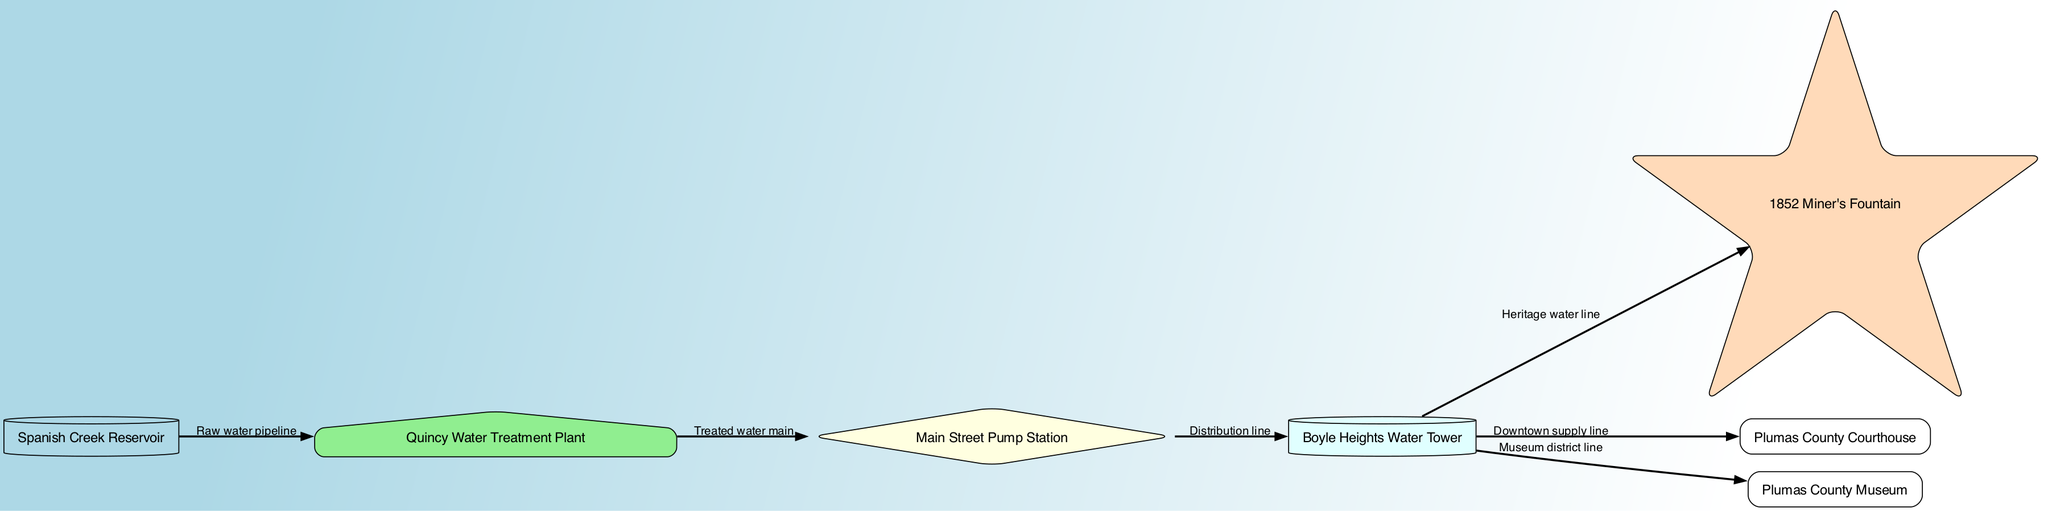What is the main water source in Quincy? The diagram indicates that the Spanish Creek Reservoir is the main water source, as it is the first node in the water distribution system.
Answer: Spanish Creek Reservoir Which facility treats the raw water? The Quincy Water Treatment Plant follows the Spanish Creek Reservoir in the flow of the water distribution system, indicating it is responsible for treating the raw water.
Answer: Quincy Water Treatment Plant How many major nodes are in the water distribution system? By counting the nodes listed in the diagram, there are a total of six major nodes representing different components of the water distribution system.
Answer: 6 What is the name of the historic water line? The diagram labels the line leading to the historic fountain as the "Heritage water line," which connects the storage tank to the fountain.
Answer: Heritage water line Which historical point of interest is supplied by the storage tank? The diagram shows that both the Plumas County Courthouse and the Plumas County Museum are supplied by distribution lines connecting them to the storage tank.
Answer: Plumas County Courthouse, Plumas County Museum What type of node is the Main Street Pump Station? The Main Street Pump Station is represented as a node with a diamond shape, indicating its role as a pump station within the water distribution system.
Answer: Diamond Which facilities receive water directly from the Boyle Heights Water Tower? The diagram indicates that the historic fountain, Plumas County Courthouse, and Plumas County Museum receive water directly from the Boyle Heights Water Tower, as they all connect to the storage tank.
Answer: Historic fountain, Plumas County Courthouse, Plumas County Museum What piping connects the reservoir to the treatment plant? The diagram specifies that a "Raw water pipeline" connects the Spanish Creek Reservoir to the Quincy Water Treatment Plant.
Answer: Raw water pipeline Where does the treated water go after the treatment plant? The diagram shows that the treated water moves from the Quincy Water Treatment Plant to the Main Street Pump Station via a line called "Treated water main."
Answer: Main Street Pump Station 